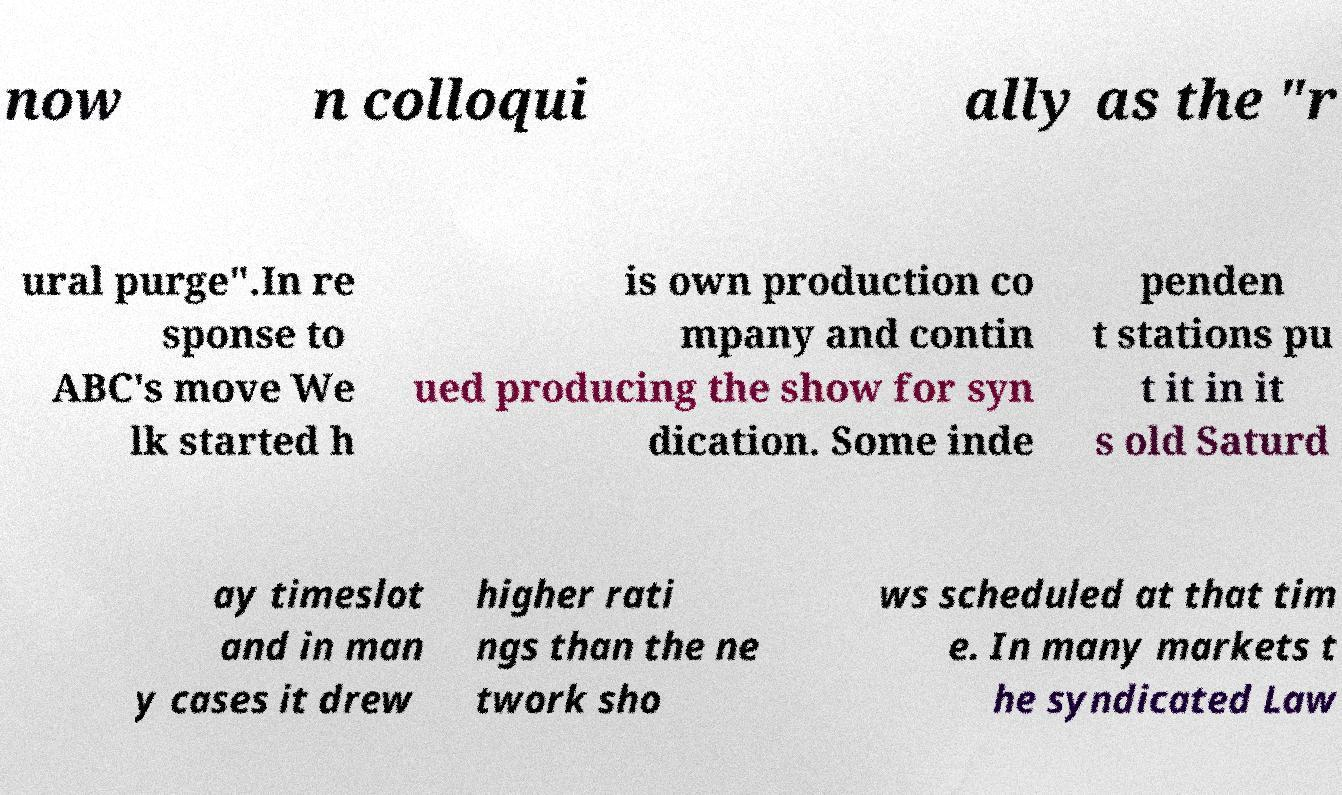Can you accurately transcribe the text from the provided image for me? now n colloqui ally as the "r ural purge".In re sponse to ABC's move We lk started h is own production co mpany and contin ued producing the show for syn dication. Some inde penden t stations pu t it in it s old Saturd ay timeslot and in man y cases it drew higher rati ngs than the ne twork sho ws scheduled at that tim e. In many markets t he syndicated Law 